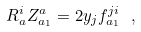<formula> <loc_0><loc_0><loc_500><loc_500>R ^ { i } _ { a } Z ^ { a } _ { a _ { 1 } } = 2 y _ { j } f ^ { j i } _ { a _ { 1 } } \ ,</formula> 